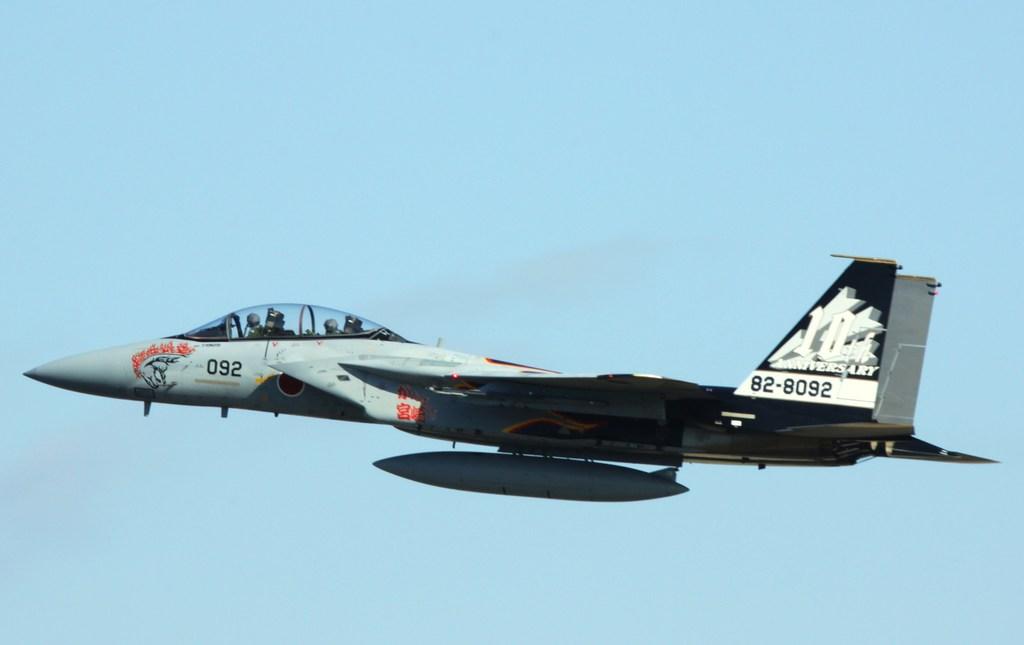What is this jets id numbers?
Offer a terse response. 82-8092. What are the numbers on the tail of the plane?
Offer a very short reply. 82-8092. 